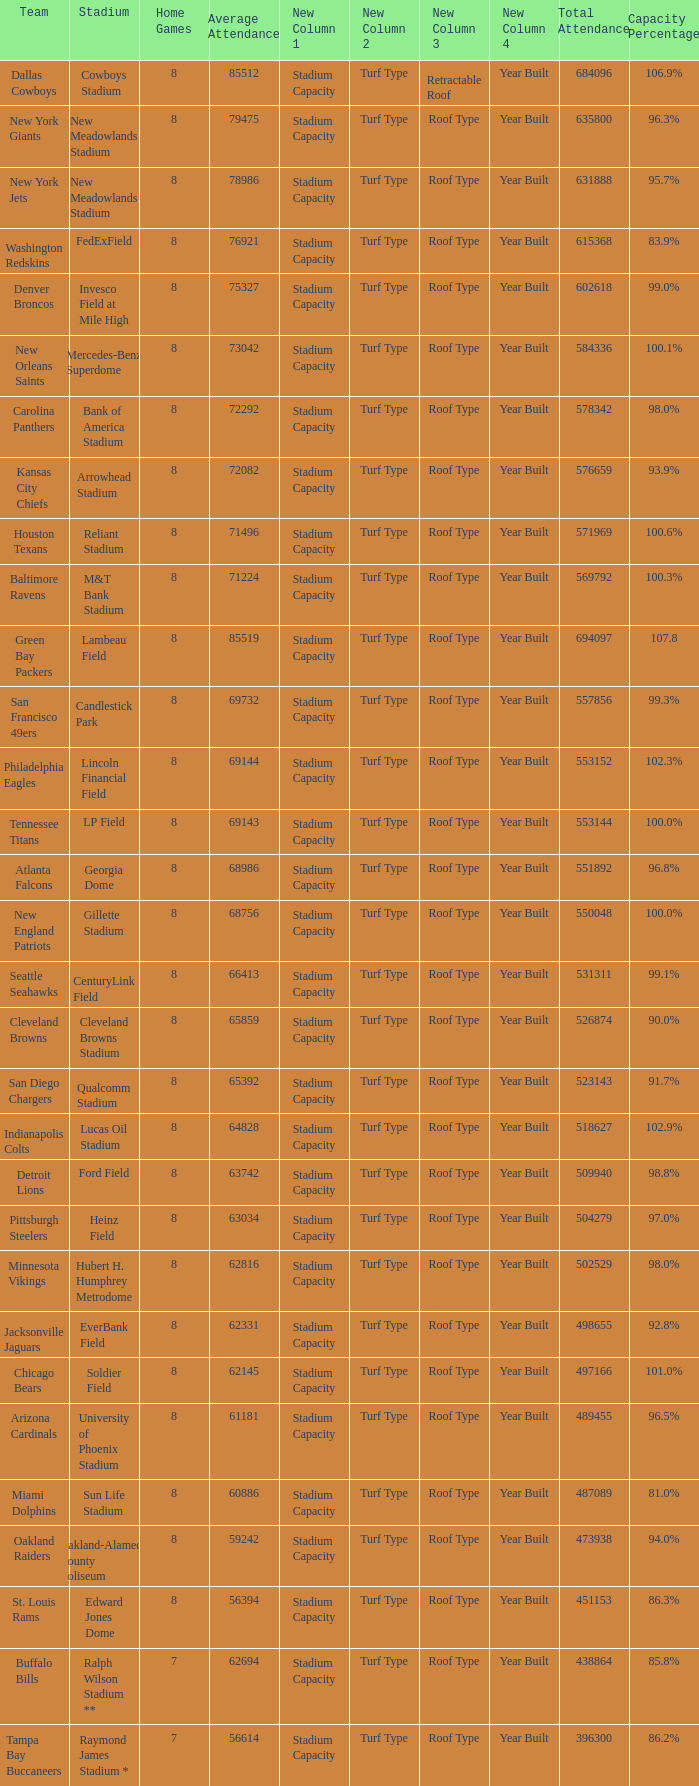How many average attendance has a capacity percentage of 96.5% 1.0. 